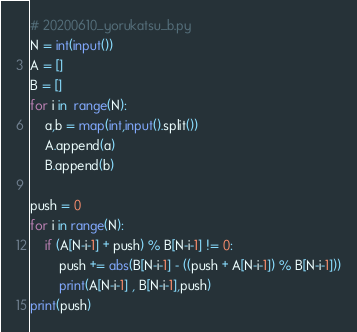<code> <loc_0><loc_0><loc_500><loc_500><_Python_># 20200610_yorukatsu_b.py
N = int(input())
A = []
B = []
for i in  range(N):
    a,b = map(int,input().split())
    A.append(a)
    B.append(b)

push = 0
for i in range(N):
    if (A[N-i-1] + push) % B[N-i-1] != 0:
        push += abs(B[N-i-1] - ((push + A[N-i-1]) % B[N-i-1]))
        print(A[N-i-1] , B[N-i-1],push)
print(push)
</code> 